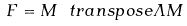<formula> <loc_0><loc_0><loc_500><loc_500>F = M ^ { \ } t r a n s p o s e \varLambda M</formula> 